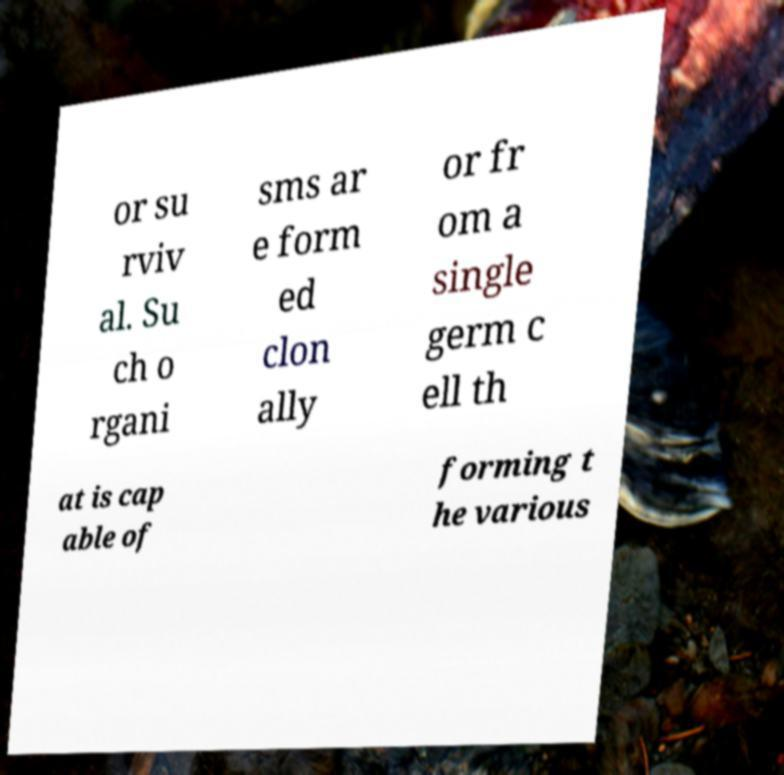Could you assist in decoding the text presented in this image and type it out clearly? or su rviv al. Su ch o rgani sms ar e form ed clon ally or fr om a single germ c ell th at is cap able of forming t he various 